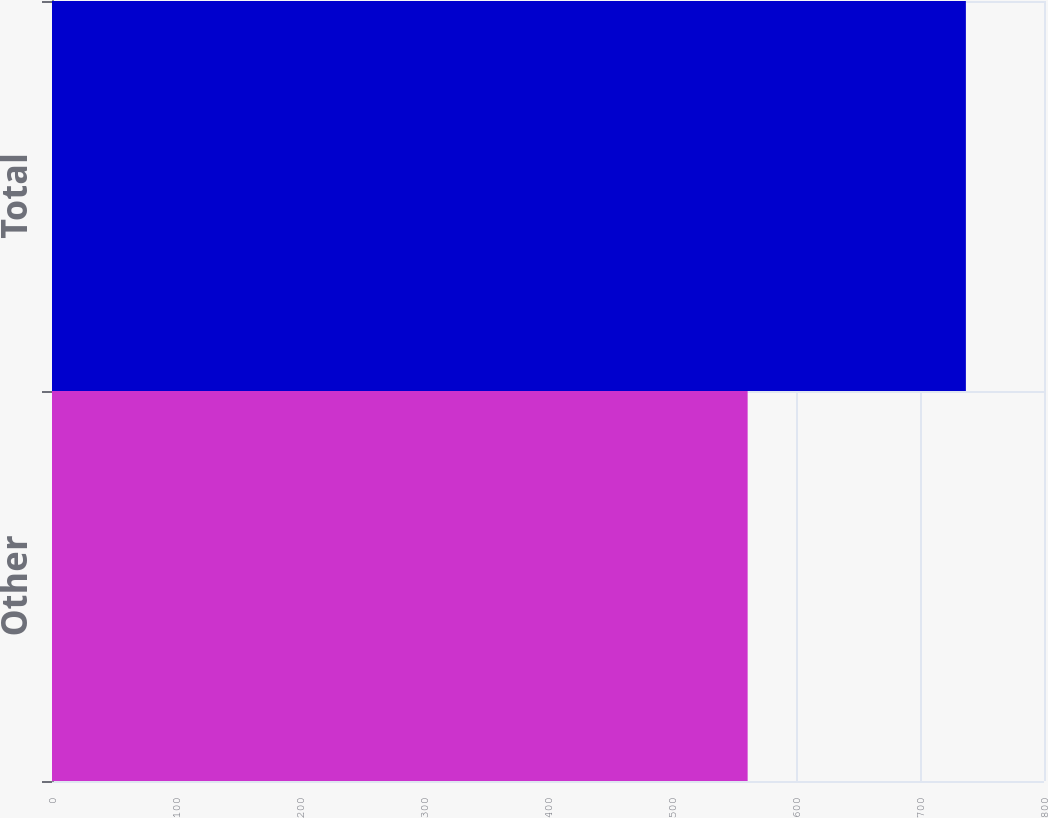Convert chart to OTSL. <chart><loc_0><loc_0><loc_500><loc_500><bar_chart><fcel>Other<fcel>Total<nl><fcel>561<fcel>737<nl></chart> 